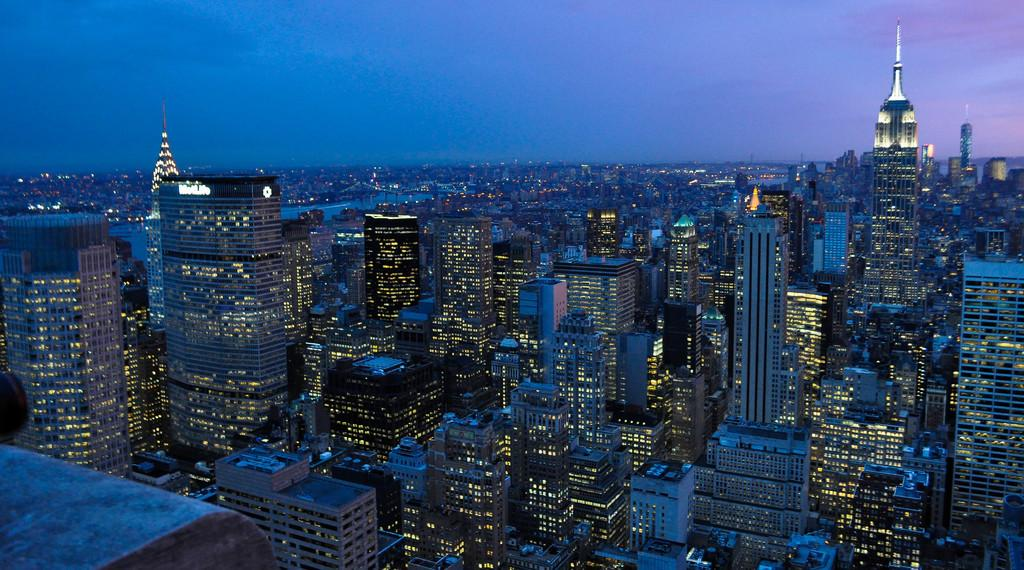What type of structures can be seen in the image? There are buildings in the image. Are there any illuminated objects in the image? Yes, there are lights in the image. What natural element is visible in the image? There is water visible in the image. What type of twig can be seen floating on the water in the image? There is no twig visible in the image; only buildings, lights, and water are present. 